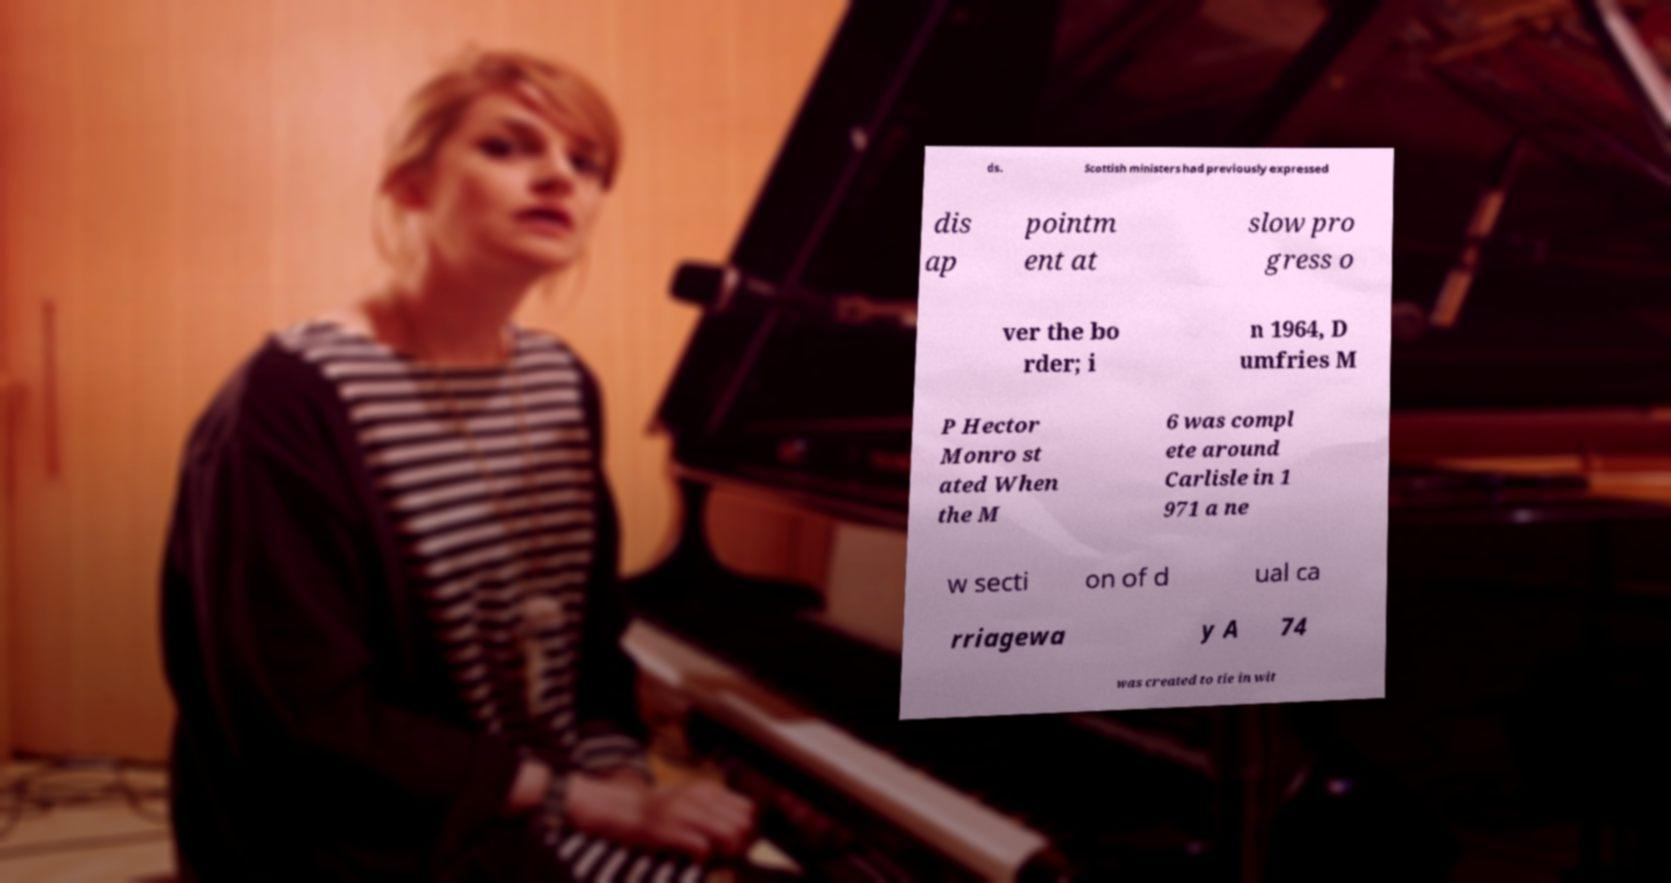Please read and relay the text visible in this image. What does it say? ds. Scottish ministers had previously expressed dis ap pointm ent at slow pro gress o ver the bo rder; i n 1964, D umfries M P Hector Monro st ated When the M 6 was compl ete around Carlisle in 1 971 a ne w secti on of d ual ca rriagewa y A 74 was created to tie in wit 